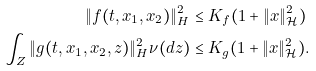Convert formula to latex. <formula><loc_0><loc_0><loc_500><loc_500>\| f ( t , x _ { 1 } , x _ { 2 } ) \| ^ { 2 } _ { H } & \leq K _ { f } ( 1 + \| x \| ^ { 2 } _ { \mathcal { H } } ) \\ \int _ { Z } \| g ( t , x _ { 1 } , x _ { 2 } , z ) \| ^ { 2 } _ { H } \nu ( d z ) & \leq K _ { g } ( 1 + \| x \| ^ { 2 } _ { \mathcal { H } } ) .</formula> 